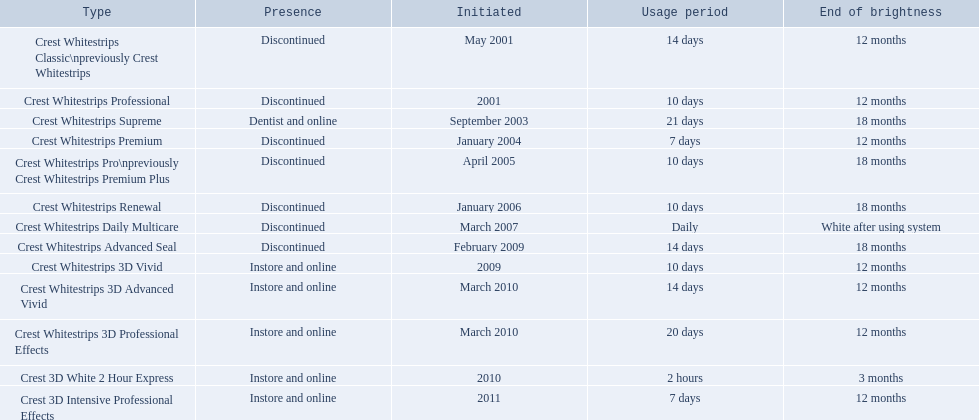Which models are still available? Crest Whitestrips Supreme, Crest Whitestrips 3D Vivid, Crest Whitestrips 3D Advanced Vivid, Crest Whitestrips 3D Professional Effects, Crest 3D White 2 Hour Express, Crest 3D Intensive Professional Effects. Of those, which were introduced prior to 2011? Crest Whitestrips Supreme, Crest Whitestrips 3D Vivid, Crest Whitestrips 3D Advanced Vivid, Crest Whitestrips 3D Professional Effects, Crest 3D White 2 Hour Express. Among those models, which ones had to be used at least 14 days? Crest Whitestrips Supreme, Crest Whitestrips 3D Advanced Vivid, Crest Whitestrips 3D Professional Effects. Which of those lasted longer than 12 months? Crest Whitestrips Supreme. 